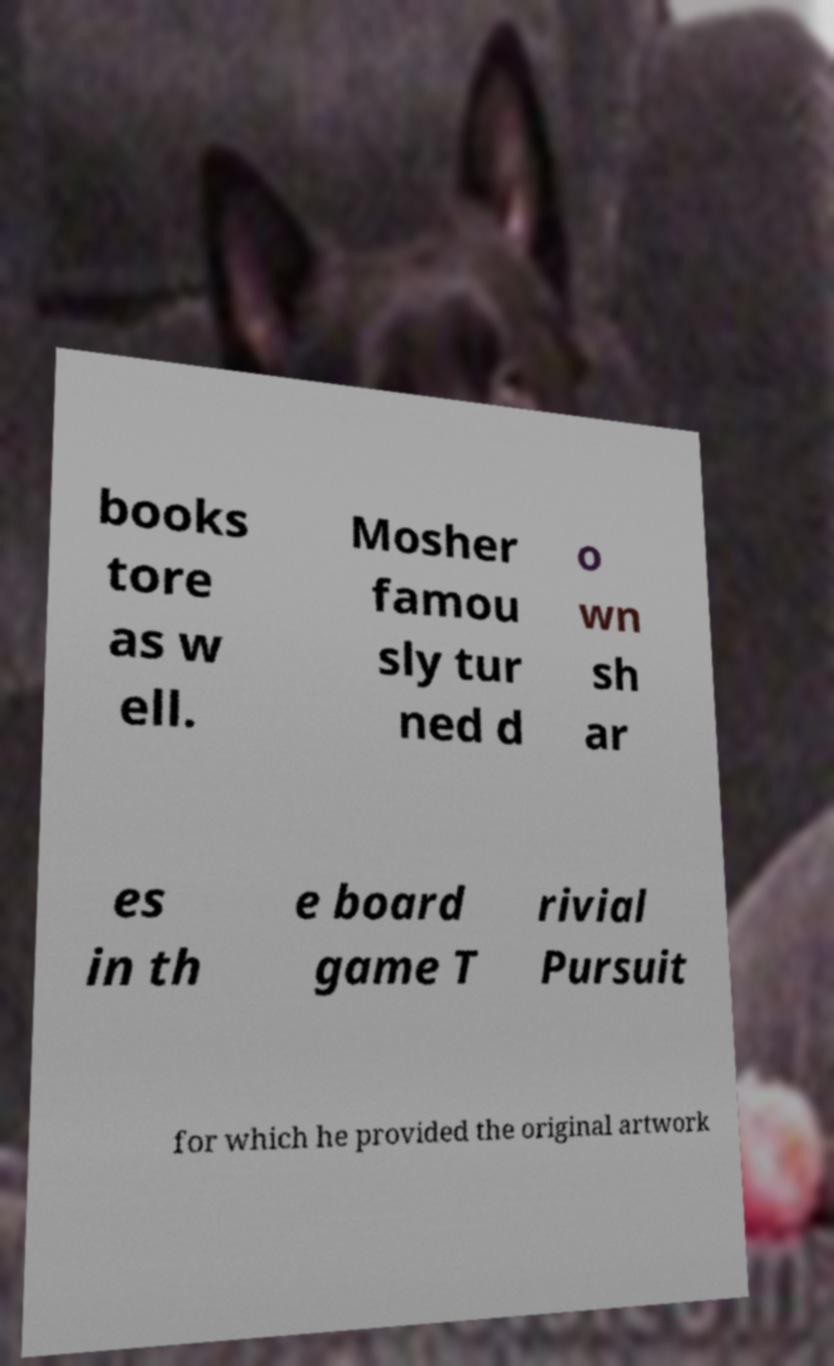Could you assist in decoding the text presented in this image and type it out clearly? books tore as w ell. Mosher famou sly tur ned d o wn sh ar es in th e board game T rivial Pursuit for which he provided the original artwork 